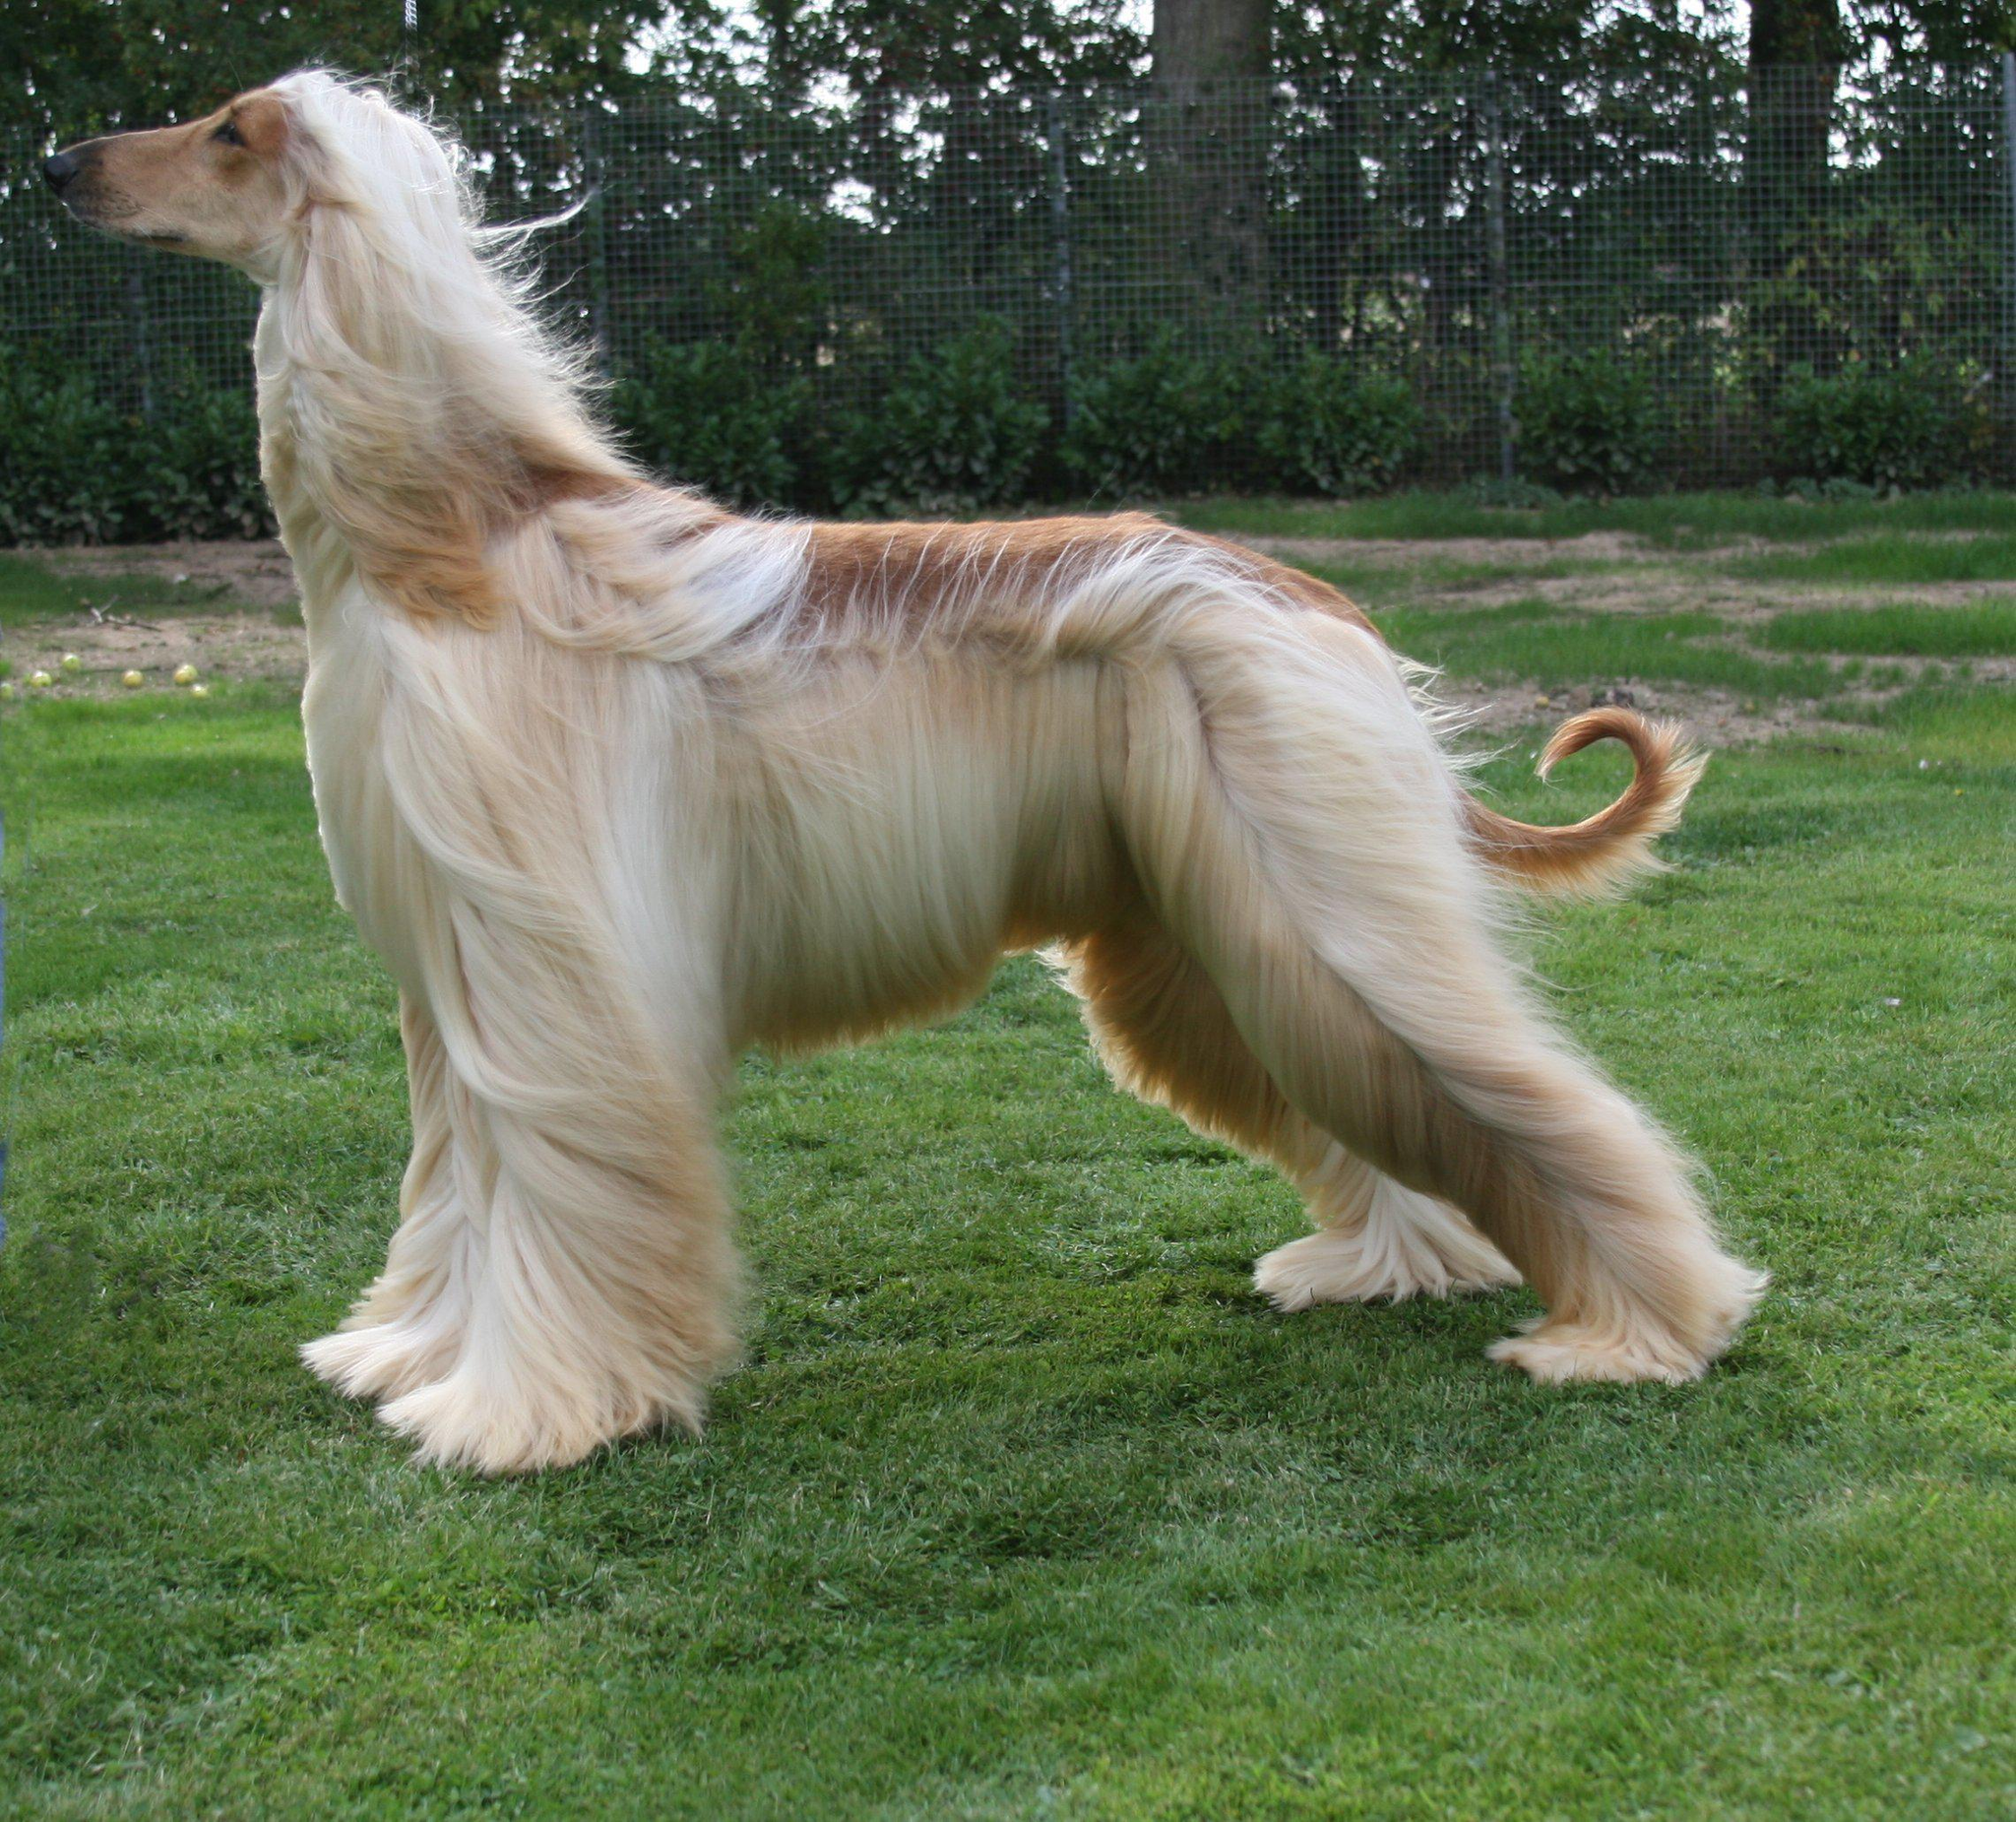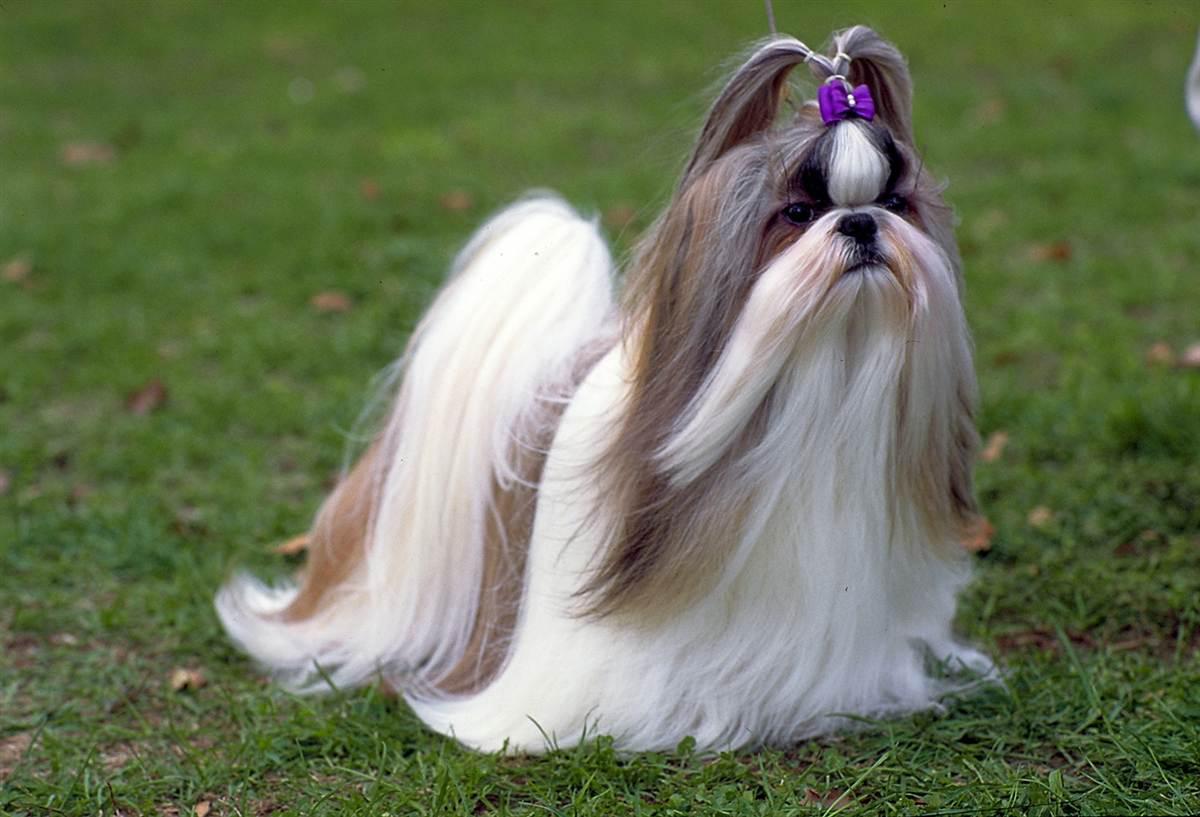The first image is the image on the left, the second image is the image on the right. Given the left and right images, does the statement "All the dogs pictured are standing on the grass." hold true? Answer yes or no. Yes. 